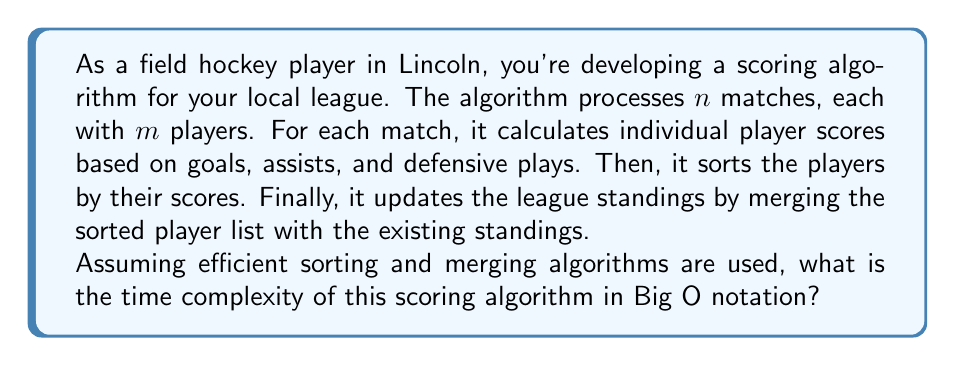What is the answer to this math problem? Let's break down the algorithm and analyze each step:

1. Processing individual matches:
   - For each of the $n$ matches, we process $m$ players
   - Time complexity: $O(n \cdot m)$

2. Sorting players for each match:
   - We use an efficient sorting algorithm (e.g., Merge Sort or Quick Sort)
   - For each match, sorting $m$ players takes $O(m \log m)$
   - We do this for $n$ matches
   - Time complexity: $O(n \cdot m \log m)$

3. Updating league standings:
   - We merge the sorted list of $m$ players into the existing standings
   - Assuming efficient merging, this takes $O(m)$ for each match
   - We do this for $n$ matches
   - Time complexity: $O(n \cdot m)$

Now, let's combine these steps:

$$T(n,m) = O(n \cdot m) + O(n \cdot m \log m) + O(n \cdot m)$$

Simplifying:

$$T(n,m) = O(n \cdot m \log m)$$

This is because $O(n \cdot m \log m)$ dominates both $O(n \cdot m)$ terms.

The time complexity is therefore $O(n \cdot m \log m)$, where $n$ is the number of matches and $m$ is the number of players per match.
Answer: $O(n \cdot m \log m)$ 